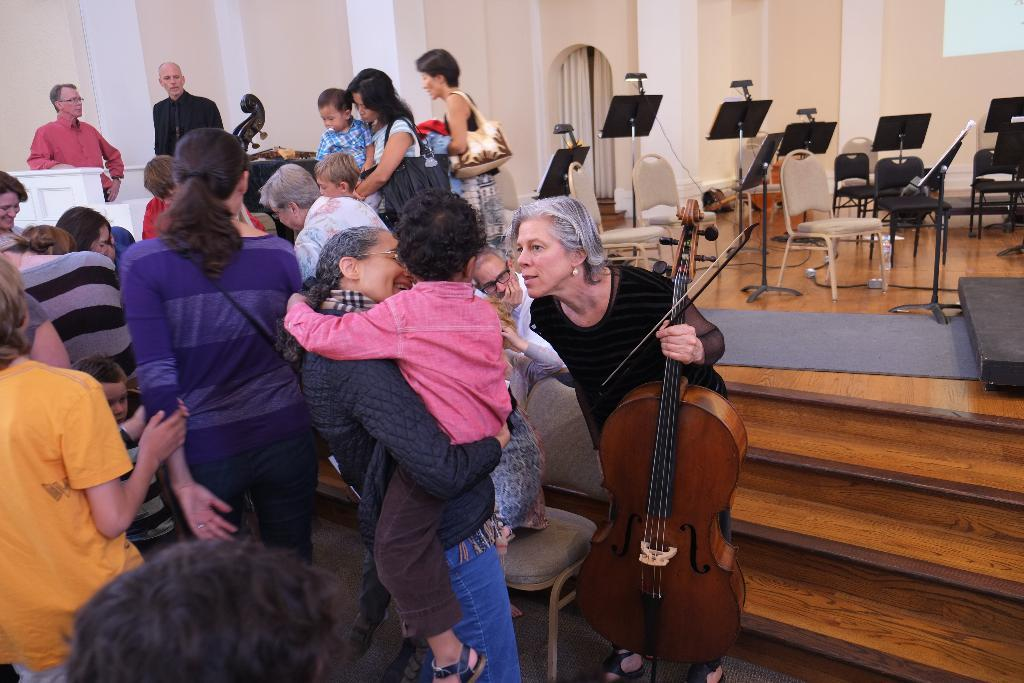How many people are in the image? There are people in the image, but the exact number is not specified. What type of furniture is present in the image? There are chairs in the image. What else can be seen in the image besides people and chairs? There are boards in the image. What is the woman holding in the image? A woman is holding a violin in the image. What type of structure is being attacked in the battle depicted in the image? There is no battle or structure present in the image; it features people, chairs, boards, and a woman holding a violin. 